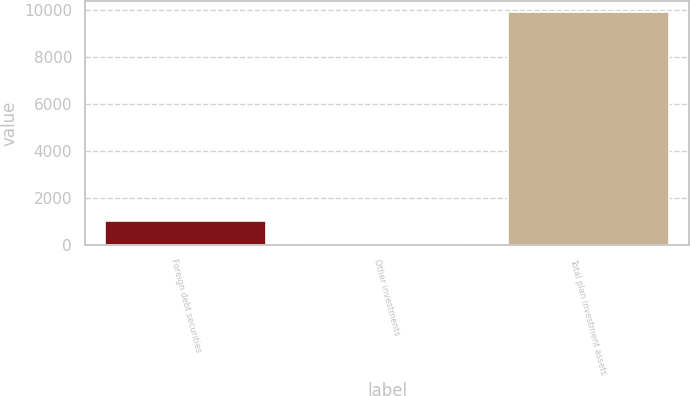<chart> <loc_0><loc_0><loc_500><loc_500><bar_chart><fcel>Foreign debt securities<fcel>Other investments<fcel>Total plan investment assets<nl><fcel>1016.4<fcel>30<fcel>9894<nl></chart> 